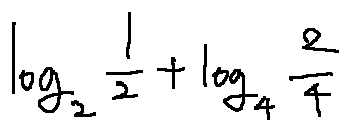Convert formula to latex. <formula><loc_0><loc_0><loc_500><loc_500>\log _ { 2 } \frac { 1 } { 2 } + \log _ { 4 } \frac { 2 } { 4 }</formula> 